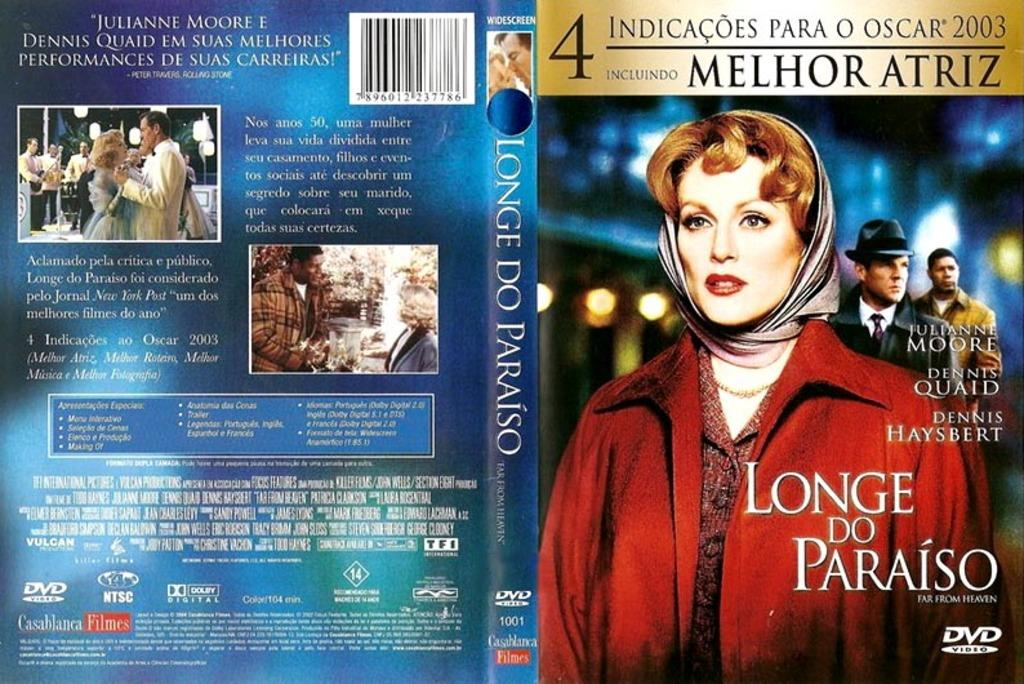<image>
Describe the image concisely. A dvd for Longe do Paraio starring Julianne Moore. 